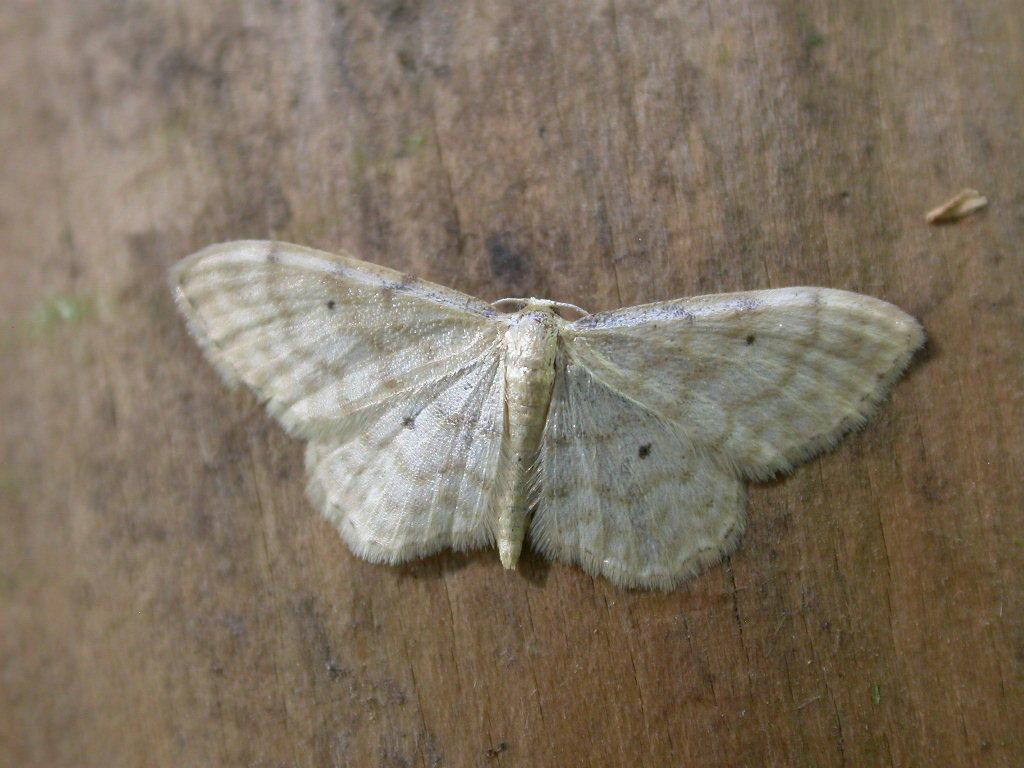What is the main subject of the image? The main subject of the image is a butterfly. On what surface is the butterfly resting? The butterfly is on a brown surface. What type of drug is the butterfly holding in the image? There is no drug present in the image, as it features a butterfly on a brown surface. 